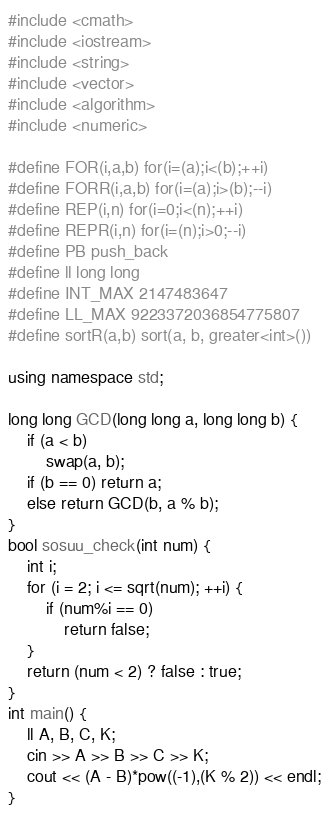Convert code to text. <code><loc_0><loc_0><loc_500><loc_500><_C++_>#include <cmath>
#include <iostream>
#include <string>
#include <vector> 
#include <algorithm>
#include <numeric>

#define FOR(i,a,b) for(i=(a);i<(b);++i) 
#define FORR(i,a,b) for(i=(a);i>(b);--i)
#define REP(i,n) for(i=0;i<(n);++i)
#define REPR(i,n) for(i=(n);i>0;--i)
#define PB push_back
#define ll long long
#define INT_MAX 2147483647
#define LL_MAX 9223372036854775807
#define sortR(a,b) sort(a, b, greater<int>())

using namespace std;

long long GCD(long long a, long long b) {
	if (a < b)
		swap(a, b);
	if (b == 0) return a;
	else return GCD(b, a % b);
}
bool sosuu_check(int num) {
	int i;
	for (i = 2; i <= sqrt(num); ++i) {
		if (num%i == 0)
			return false;
	}
	return (num < 2) ? false : true;
}
int main() {
	ll A, B, C, K;
	cin >> A >> B >> C >> K;
	cout << (A - B)*pow((-1),(K % 2)) << endl;
}</code> 